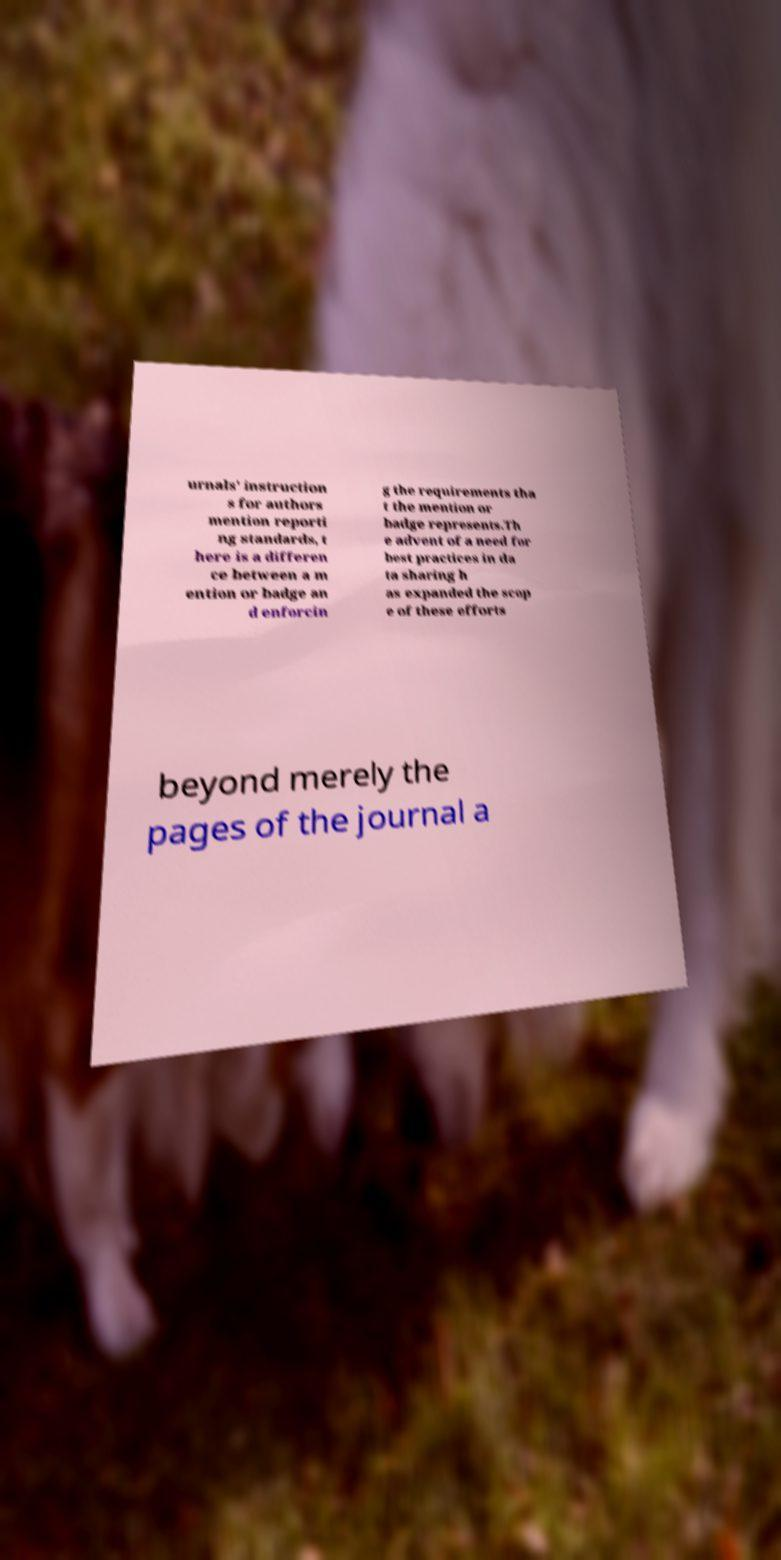Can you read and provide the text displayed in the image?This photo seems to have some interesting text. Can you extract and type it out for me? urnals' instruction s for authors mention reporti ng standards, t here is a differen ce between a m ention or badge an d enforcin g the requirements tha t the mention or badge represents.Th e advent of a need for best practices in da ta sharing h as expanded the scop e of these efforts beyond merely the pages of the journal a 